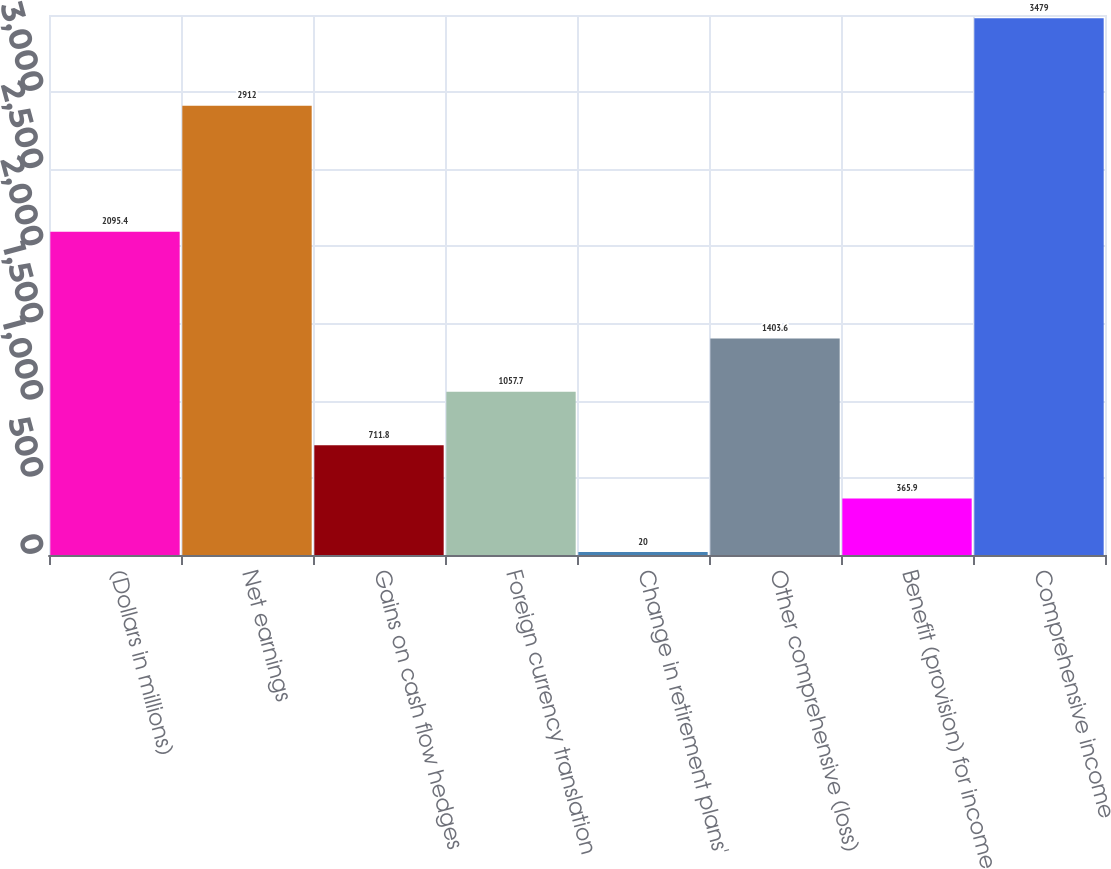Convert chart. <chart><loc_0><loc_0><loc_500><loc_500><bar_chart><fcel>(Dollars in millions)<fcel>Net earnings<fcel>Gains on cash flow hedges<fcel>Foreign currency translation<fcel>Change in retirement plans'<fcel>Other comprehensive (loss)<fcel>Benefit (provision) for income<fcel>Comprehensive income<nl><fcel>2095.4<fcel>2912<fcel>711.8<fcel>1057.7<fcel>20<fcel>1403.6<fcel>365.9<fcel>3479<nl></chart> 